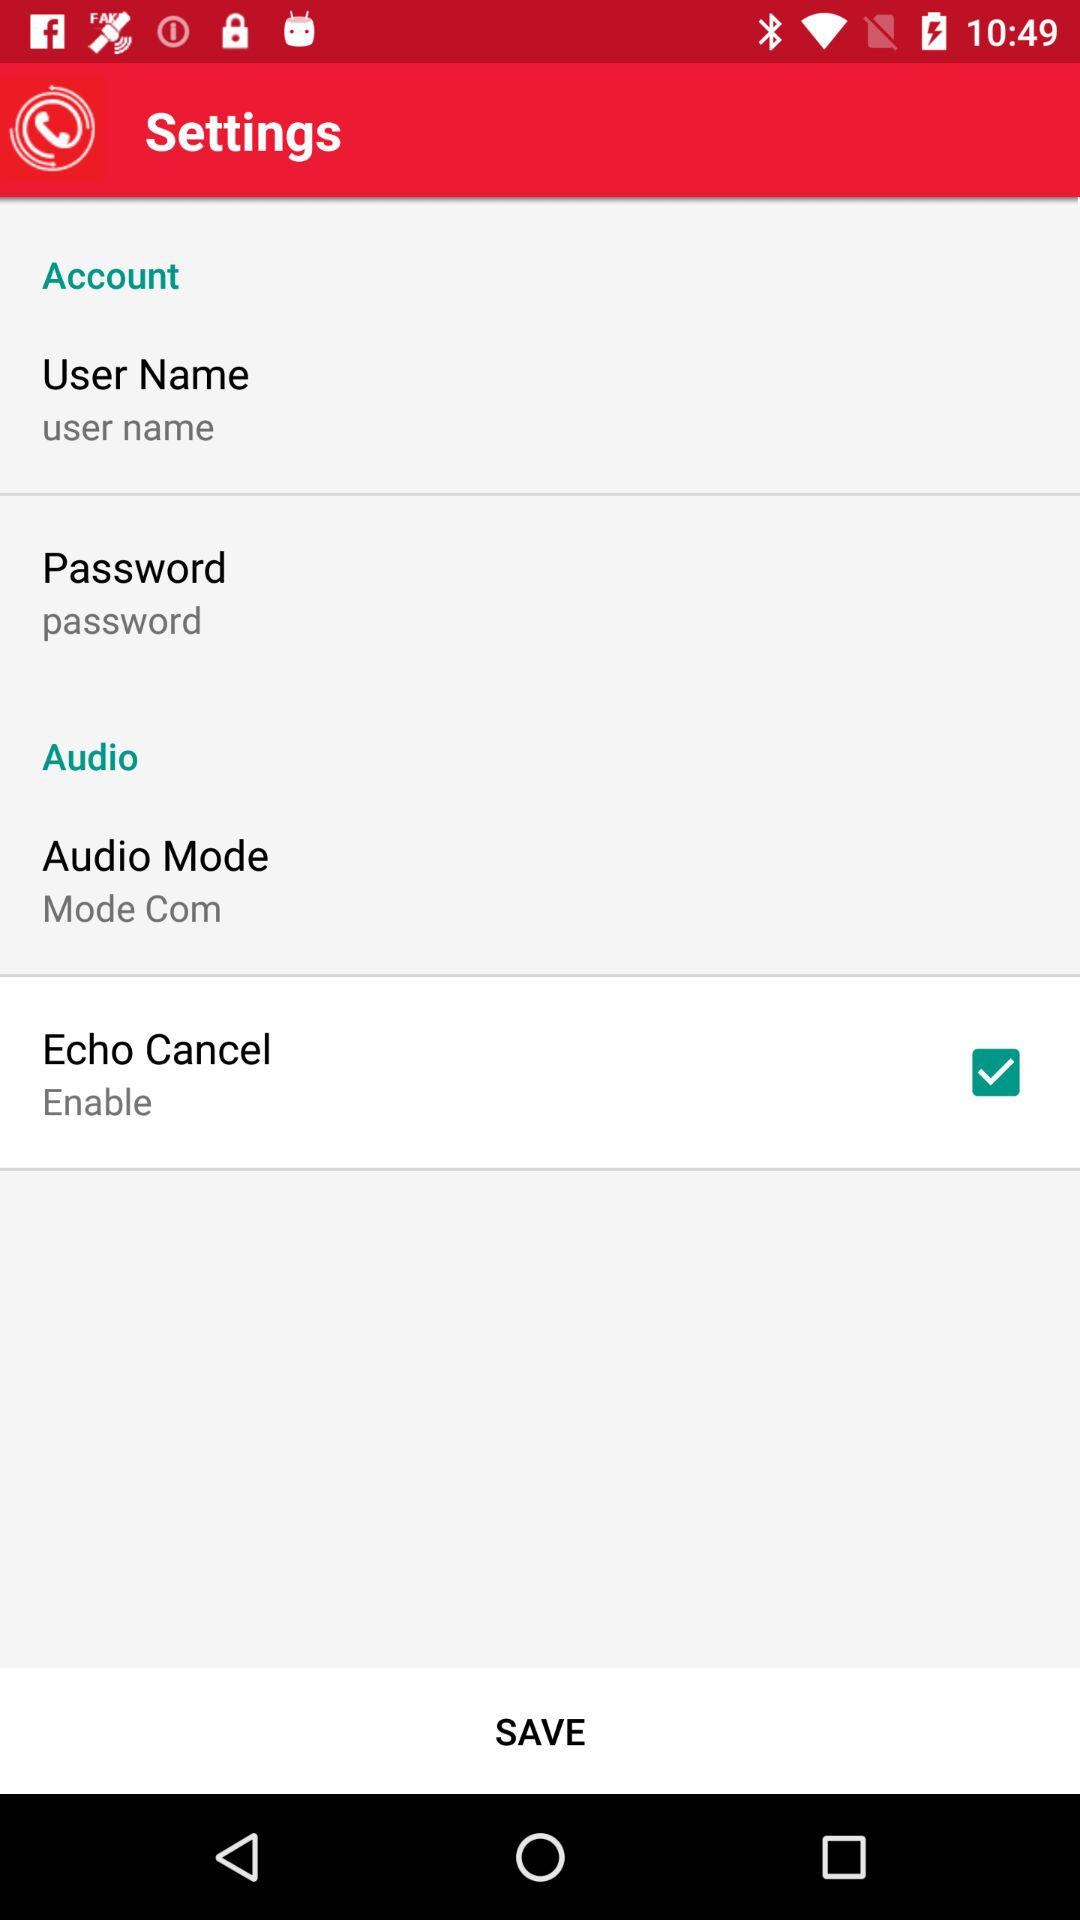Which audio mode is used? The used audio mode is mode com. 